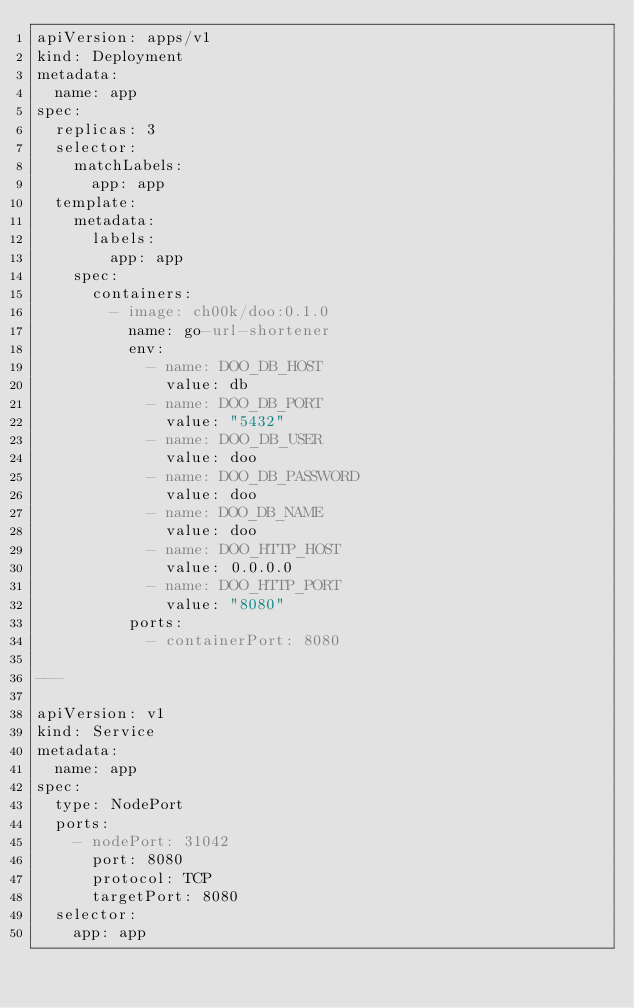Convert code to text. <code><loc_0><loc_0><loc_500><loc_500><_YAML_>apiVersion: apps/v1
kind: Deployment
metadata:
  name: app
spec:
  replicas: 3
  selector:
    matchLabels:
      app: app
  template:
    metadata:
      labels:
        app: app
    spec:
      containers:
        - image: ch00k/doo:0.1.0
          name: go-url-shortener
          env:
            - name: DOO_DB_HOST
              value: db
            - name: DOO_DB_PORT
              value: "5432"
            - name: DOO_DB_USER
              value: doo
            - name: DOO_DB_PASSWORD
              value: doo
            - name: DOO_DB_NAME
              value: doo
            - name: DOO_HTTP_HOST
              value: 0.0.0.0
            - name: DOO_HTTP_PORT
              value: "8080"
          ports:
            - containerPort: 8080

---

apiVersion: v1
kind: Service
metadata:
  name: app
spec:
  type: NodePort
  ports:
    - nodePort: 31042
      port: 8080
      protocol: TCP
      targetPort: 8080
  selector:
    app: app
</code> 